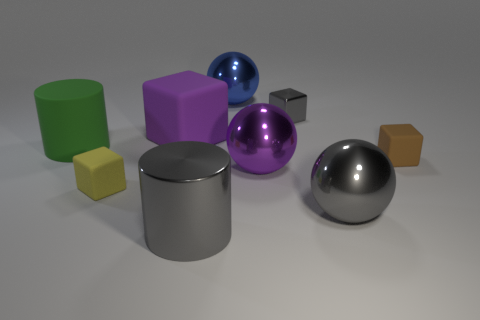There is a gray block that is the same size as the brown matte block; what is it made of?
Offer a very short reply. Metal. There is a green rubber thing; is its size the same as the shiny sphere in front of the small yellow rubber object?
Provide a short and direct response. Yes. What is the small brown block on the right side of the big blue sphere made of?
Provide a succinct answer. Rubber. Is the number of purple matte cubes that are behind the purple matte cube the same as the number of yellow rubber blocks?
Provide a succinct answer. No. Do the purple rubber thing and the gray ball have the same size?
Provide a succinct answer. Yes. There is a large shiny cylinder in front of the small matte object right of the yellow thing; are there any large metal cylinders that are left of it?
Your answer should be very brief. No. There is a purple object that is the same shape as the big blue object; what is its material?
Provide a short and direct response. Metal. There is a big ball that is to the right of the gray cube; what number of cylinders are behind it?
Provide a short and direct response. 1. There is a blue thing that is behind the gray object that is left of the small block behind the brown object; what size is it?
Your answer should be compact. Large. There is a small matte thing to the left of the shiny sphere that is behind the large green rubber object; what color is it?
Your answer should be compact. Yellow. 